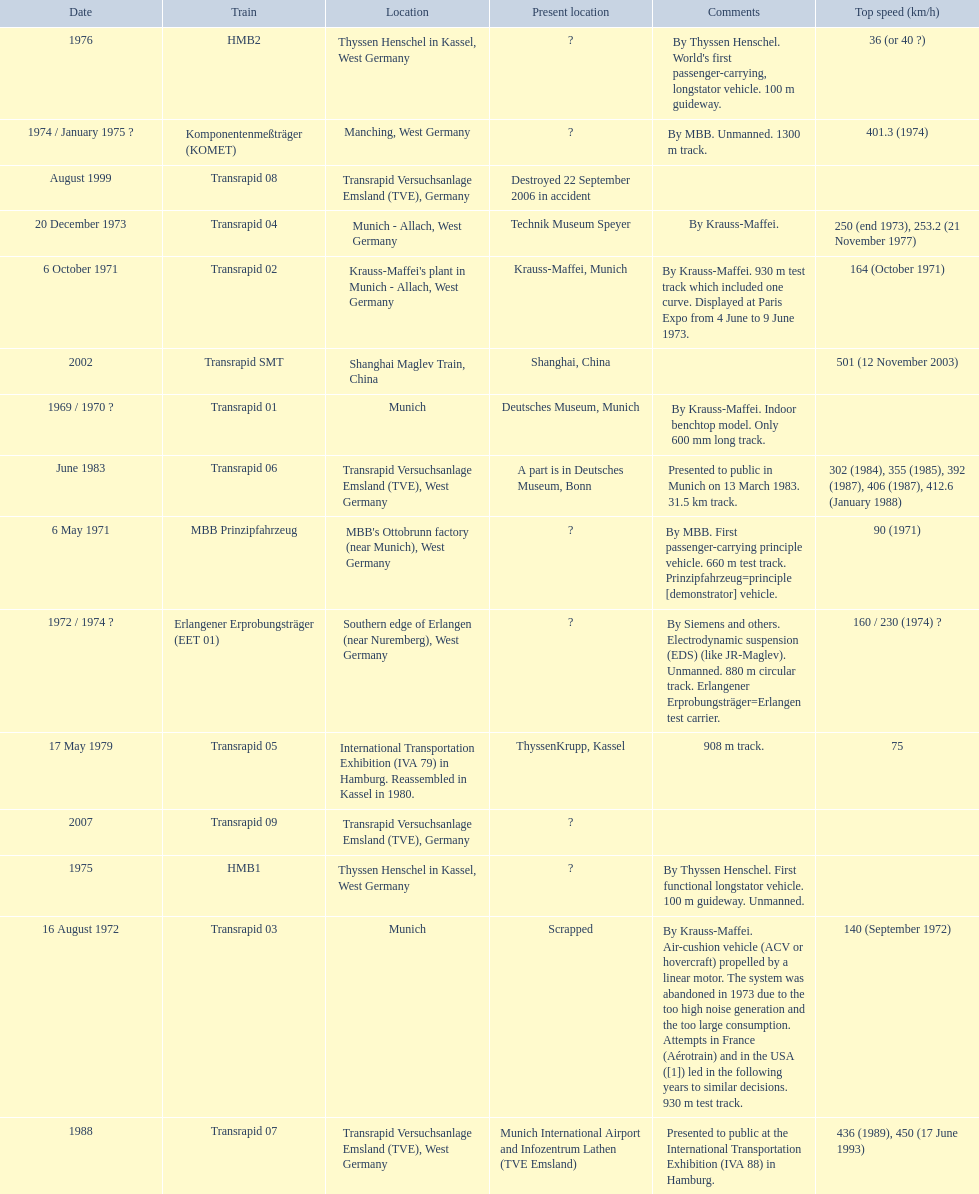What are all of the transrapid trains? Transrapid 01, Transrapid 02, Transrapid 03, Transrapid 04, Transrapid 05, Transrapid 06, Transrapid 07, Transrapid 08, Transrapid SMT, Transrapid 09. Of those, which train had to be scrapped? Transrapid 03. Could you help me parse every detail presented in this table? {'header': ['Date', 'Train', 'Location', 'Present location', 'Comments', 'Top speed (km/h)'], 'rows': [['1976', 'HMB2', 'Thyssen Henschel in Kassel, West Germany', '?', "By Thyssen Henschel. World's first passenger-carrying, longstator vehicle. 100 m guideway.", '36 (or 40\xa0?)'], ['1974 / January 1975\xa0?', 'Komponentenmeßträger (KOMET)', 'Manching, West Germany', '?', 'By MBB. Unmanned. 1300 m track.', '401.3 (1974)'], ['August 1999', 'Transrapid 08', 'Transrapid Versuchsanlage Emsland (TVE), Germany', 'Destroyed 22 September 2006 in accident', '', ''], ['20 December 1973', 'Transrapid 04', 'Munich - Allach, West Germany', 'Technik Museum Speyer', 'By Krauss-Maffei.', '250 (end 1973), 253.2 (21 November 1977)'], ['6 October 1971', 'Transrapid 02', "Krauss-Maffei's plant in Munich - Allach, West Germany", 'Krauss-Maffei, Munich', 'By Krauss-Maffei. 930 m test track which included one curve. Displayed at Paris Expo from 4 June to 9 June 1973.', '164 (October 1971)'], ['2002', 'Transrapid SMT', 'Shanghai Maglev Train, China', 'Shanghai, China', '', '501 (12 November 2003)'], ['1969 / 1970\xa0?', 'Transrapid 01', 'Munich', 'Deutsches Museum, Munich', 'By Krauss-Maffei. Indoor benchtop model. Only 600\xa0mm long track.', ''], ['June 1983', 'Transrapid 06', 'Transrapid Versuchsanlage Emsland (TVE), West Germany', 'A part is in Deutsches Museum, Bonn', 'Presented to public in Munich on 13 March 1983. 31.5\xa0km track.', '302 (1984), 355 (1985), 392 (1987), 406 (1987), 412.6 (January 1988)'], ['6 May 1971', 'MBB Prinzipfahrzeug', "MBB's Ottobrunn factory (near Munich), West Germany", '?', 'By MBB. First passenger-carrying principle vehicle. 660 m test track. Prinzipfahrzeug=principle [demonstrator] vehicle.', '90 (1971)'], ['1972 / 1974\xa0?', 'Erlangener Erprobungsträger (EET 01)', 'Southern edge of Erlangen (near Nuremberg), West Germany', '?', 'By Siemens and others. Electrodynamic suspension (EDS) (like JR-Maglev). Unmanned. 880 m circular track. Erlangener Erprobungsträger=Erlangen test carrier.', '160 / 230 (1974)\xa0?'], ['17 May 1979', 'Transrapid 05', 'International Transportation Exhibition (IVA 79) in Hamburg. Reassembled in Kassel in 1980.', 'ThyssenKrupp, Kassel', '908 m track.', '75'], ['2007', 'Transrapid 09', 'Transrapid Versuchsanlage Emsland (TVE), Germany', '?', '', ''], ['1975', 'HMB1', 'Thyssen Henschel in Kassel, West Germany', '?', 'By Thyssen Henschel. First functional longstator vehicle. 100 m guideway. Unmanned.', ''], ['16 August 1972', 'Transrapid 03', 'Munich', 'Scrapped', 'By Krauss-Maffei. Air-cushion vehicle (ACV or hovercraft) propelled by a linear motor. The system was abandoned in 1973 due to the too high noise generation and the too large consumption. Attempts in France (Aérotrain) and in the USA ([1]) led in the following years to similar decisions. 930 m test track.', '140 (September 1972)'], ['1988', 'Transrapid 07', 'Transrapid Versuchsanlage Emsland (TVE), West Germany', 'Munich International Airport and Infozentrum Lathen (TVE Emsland)', 'Presented to public at the International Transportation Exhibition (IVA 88) in Hamburg.', '436 (1989), 450 (17 June 1993)']]} 